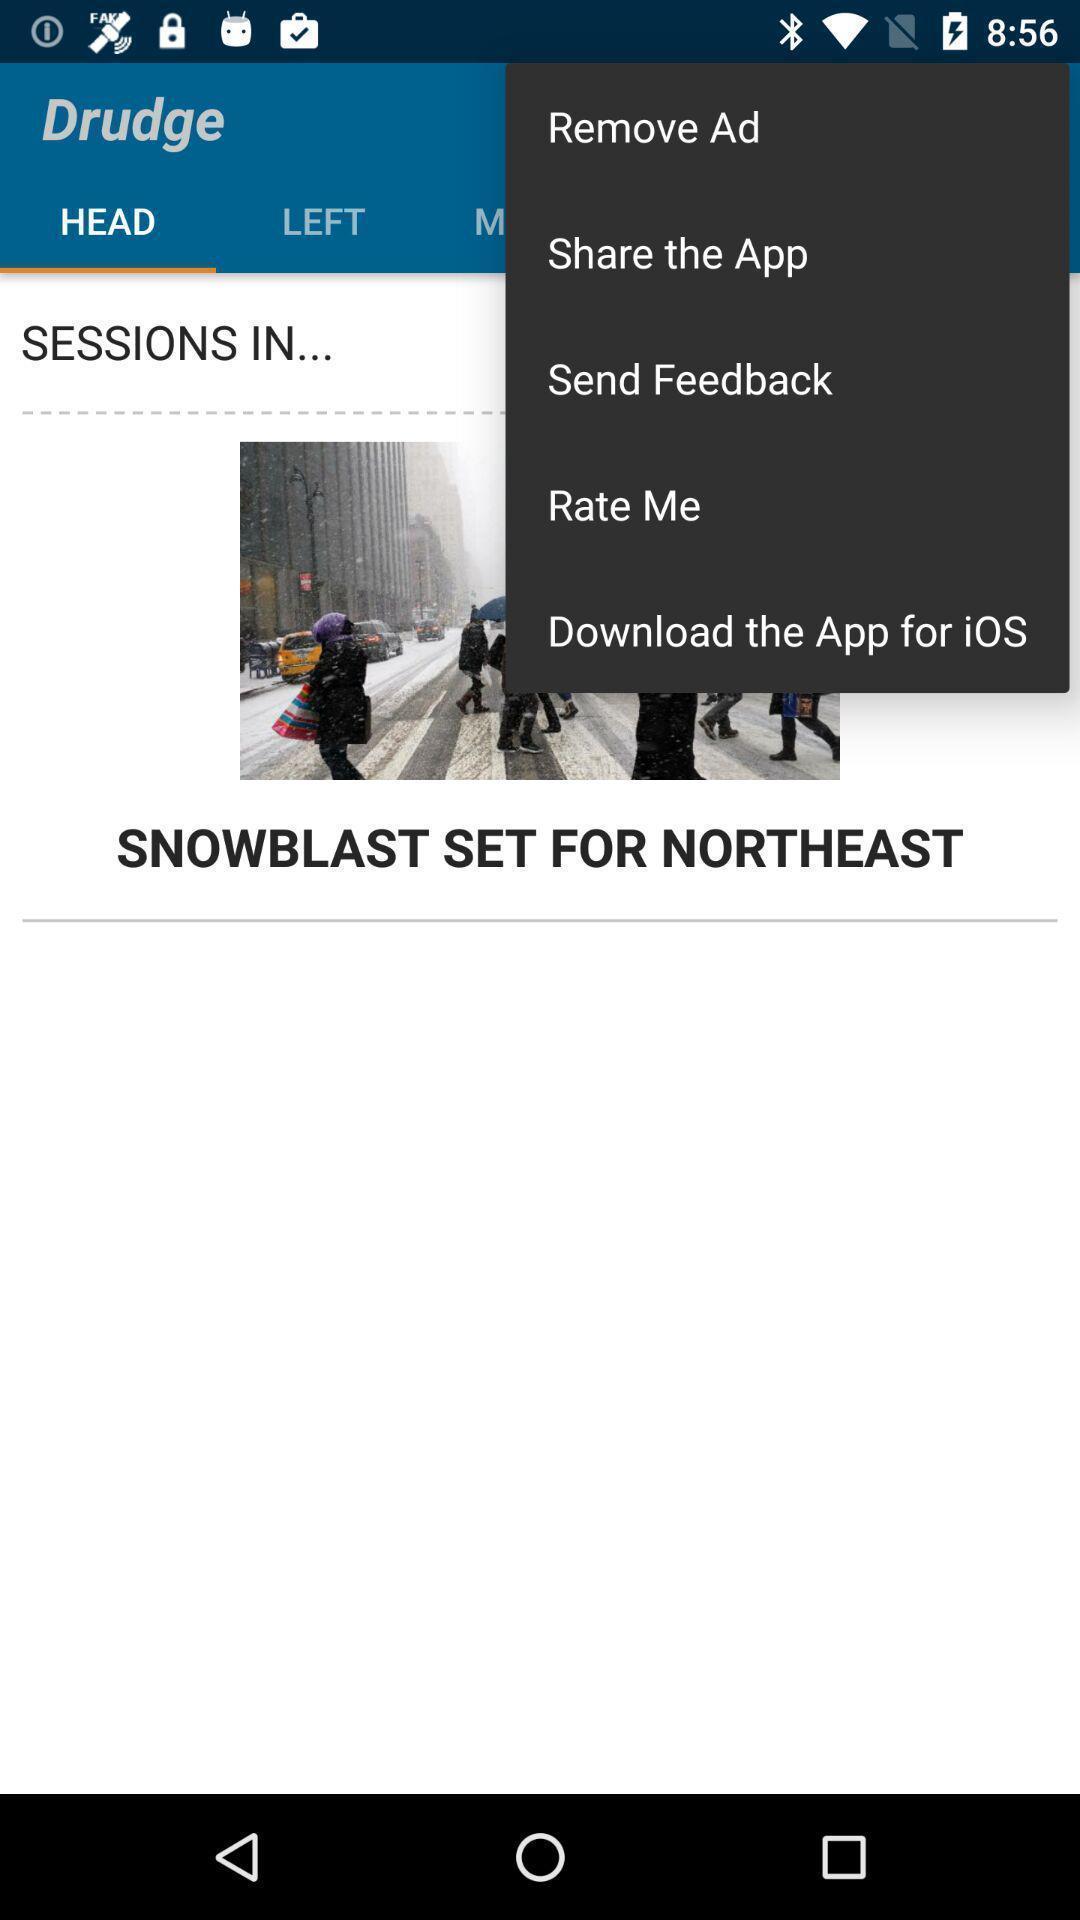Explain the elements present in this screenshot. Pop-up showing the multiple options. 